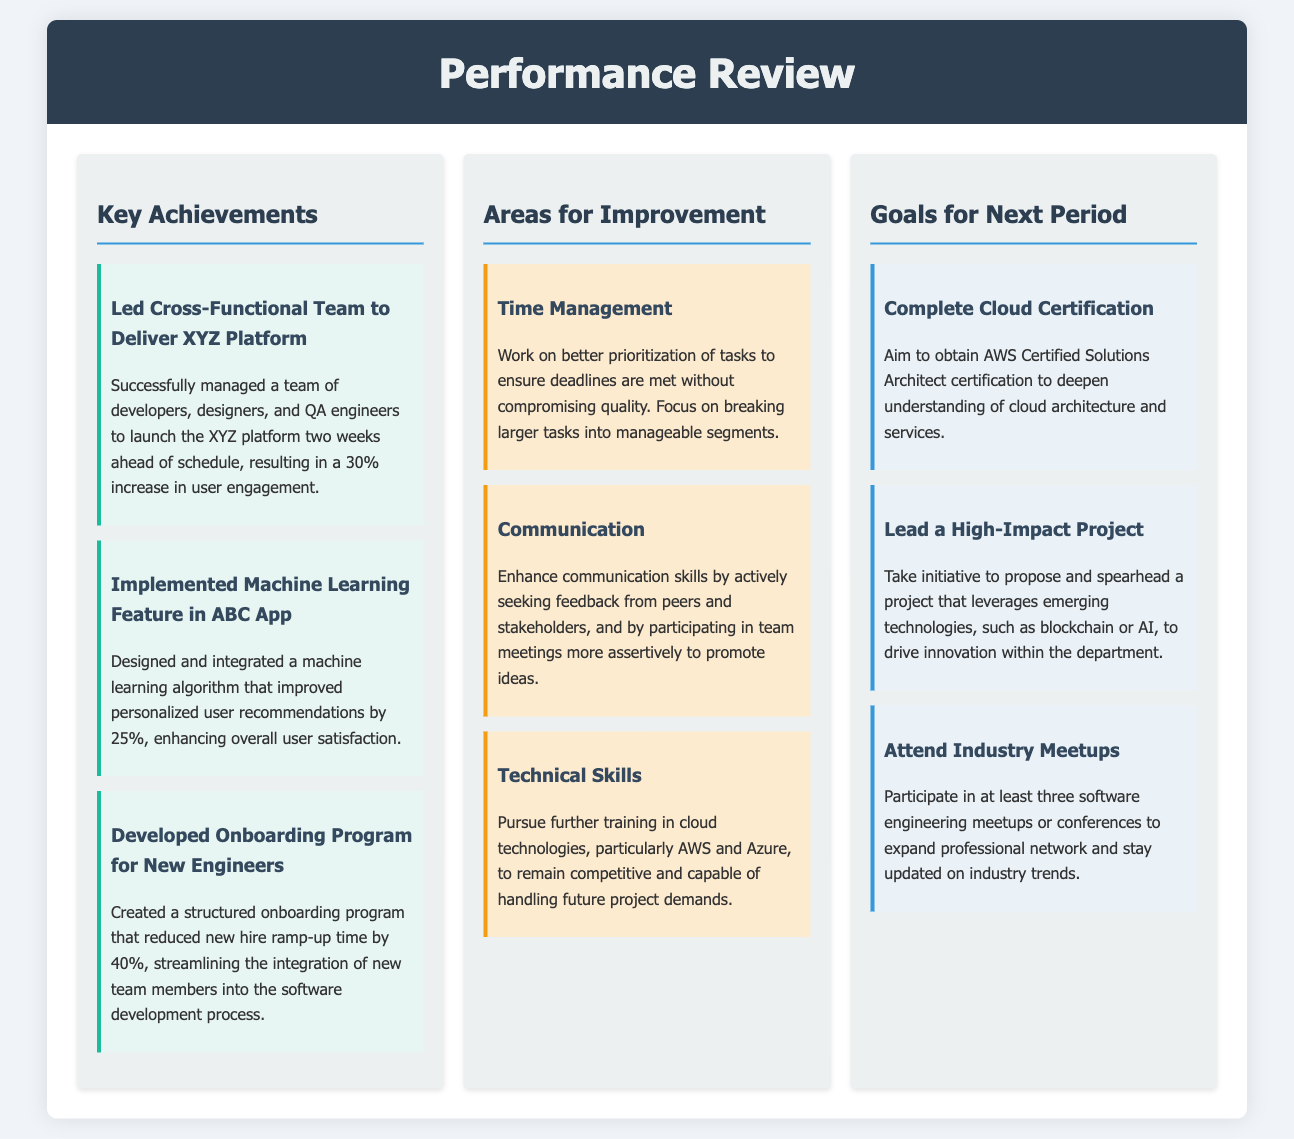What is the title of the document? The title of the document is located in the header and describes the main content of the document.
Answer: Performance Review How many key achievements are listed? The number of key achievements is found by counting the items in the Key Achievements section.
Answer: 3 What was the percentage increase in user engagement after launching the XYZ platform? The document specifies the impact of the XYZ platform launch in terms of user engagement.
Answer: 30% What area for improvement focuses on better prioritization of tasks? This area can be found in the Areas for Improvement section and emphasizes the need to enhance efficiency in task management.
Answer: Time Management Which certification is aimed to be completed in the goals for the next period? This certification is mentioned specifically in the Goals for Next Period section, indicating a target for the upcoming review period.
Answer: AWS Certified Solutions Architect What is the goal related to expanding the professional network? The document lists several goals, and one specifically addresses networking opportunities within the industry.
Answer: Attend Industry Meetups Which achievement involved designing a machine learning feature? This achievement can be found in the Key Achievements section, detailing a significant contribution to the ABC app.
Answer: Implemented Machine Learning Feature in ABC App How does the document categorize the suggestions for improvement? The document has clear sections that label areas needing enhancement, differentiating them by themes.
Answer: Areas for Improvement What innovative technologies are suggested for a future project lead? The document mentions exploring technologies in a specific context for further project development.
Answer: Blockchain or AI 